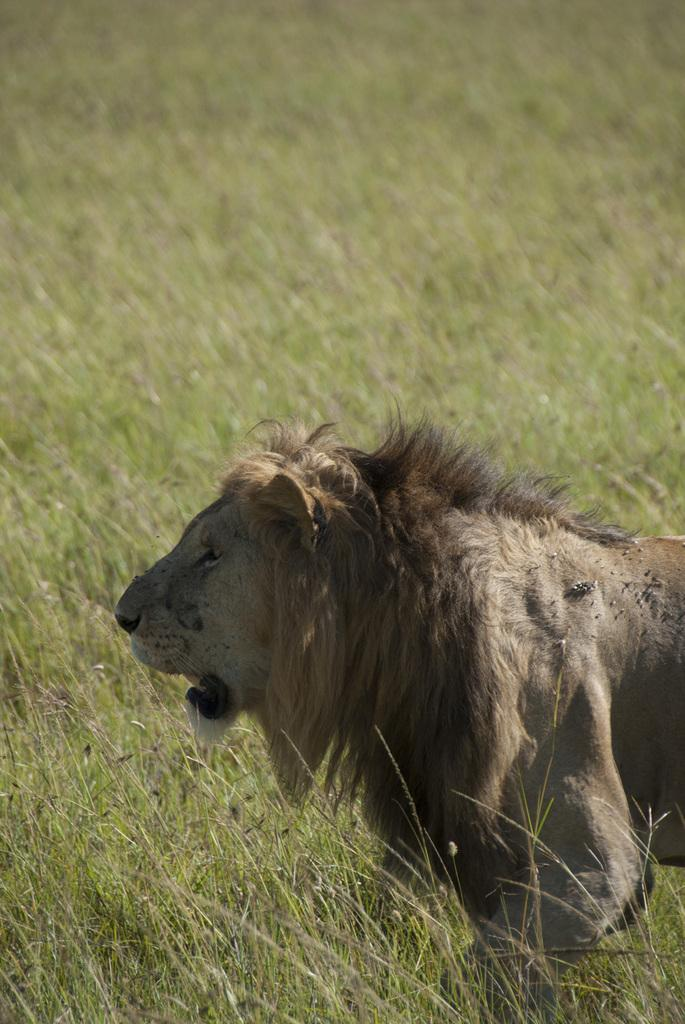What animal is the main subject of the image? There is a lion in the image. Where is the lion located in the image? The lion is on the right side of the image. What type of environment can be seen in the background of the image? There is grass in the background of the image. What type of ornament is hanging from the lion's neck in the image? There is no ornament hanging from the lion's neck in the image; the lion is not adorned with any accessories. 